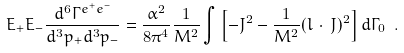Convert formula to latex. <formula><loc_0><loc_0><loc_500><loc_500>E _ { + } E _ { - } \frac { d ^ { 6 } \Gamma ^ { e ^ { + } e ^ { - } } } { d ^ { 3 } p _ { + } d ^ { 3 } p _ { - } } = \frac { \alpha ^ { 2 } } { 8 \pi ^ { 4 } } \frac { 1 } { M ^ { 2 } } \int \left [ - J ^ { 2 } - \frac { 1 } { M ^ { 2 } } ( l \, \cdot \, J ) ^ { 2 } \right ] d \Gamma _ { 0 } \ .</formula> 